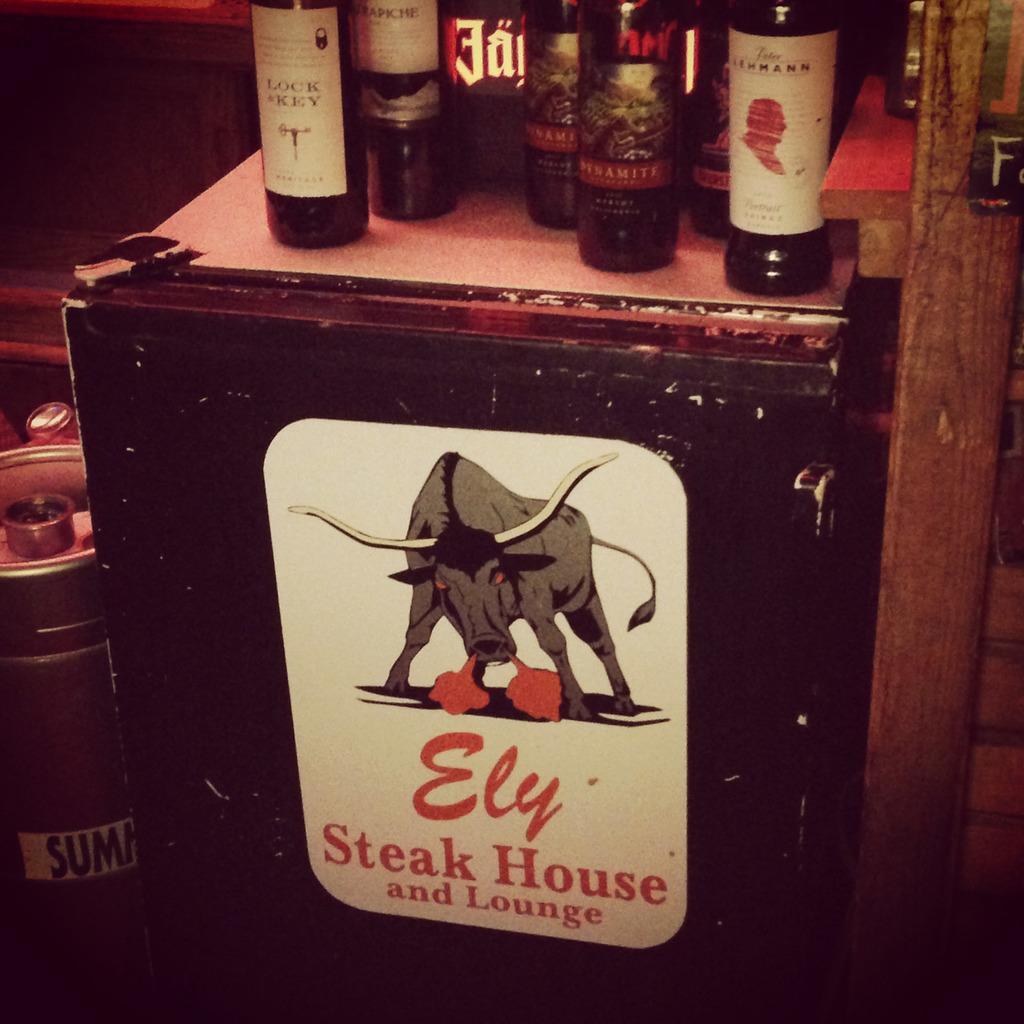Describe this image in one or two sentences. In this image I see the bottles on which there are stickers on it and they're on the red surface and I see a picture of a bull and I see few words written over here and I see few things over here and I see the wooden thing and it is dark over here and here. 